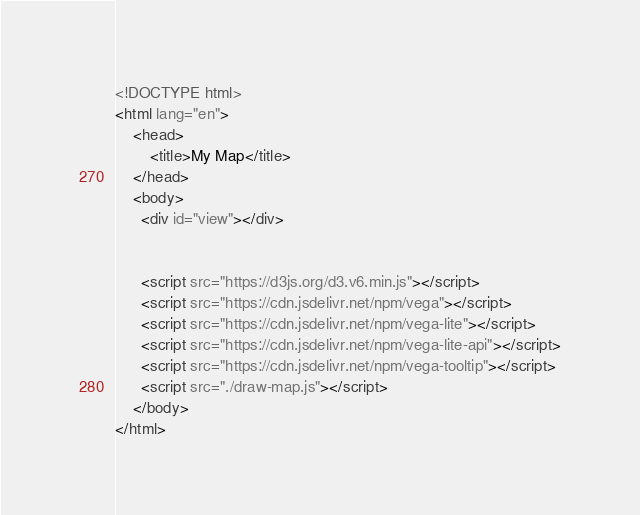Convert code to text. <code><loc_0><loc_0><loc_500><loc_500><_HTML_><!DOCTYPE html>
<html lang="en">
    <head>
        <title>My Map</title>
    </head>
    <body>
      <div id="view"></div>


      <script src="https://d3js.org/d3.v6.min.js"></script>
      <script src="https://cdn.jsdelivr.net/npm/vega"></script>
      <script src="https://cdn.jsdelivr.net/npm/vega-lite"></script>
      <script src="https://cdn.jsdelivr.net/npm/vega-lite-api"></script>
      <script src="https://cdn.jsdelivr.net/npm/vega-tooltip"></script>
      <script src="./draw-map.js"></script>
    </body>
</html>
</code> 